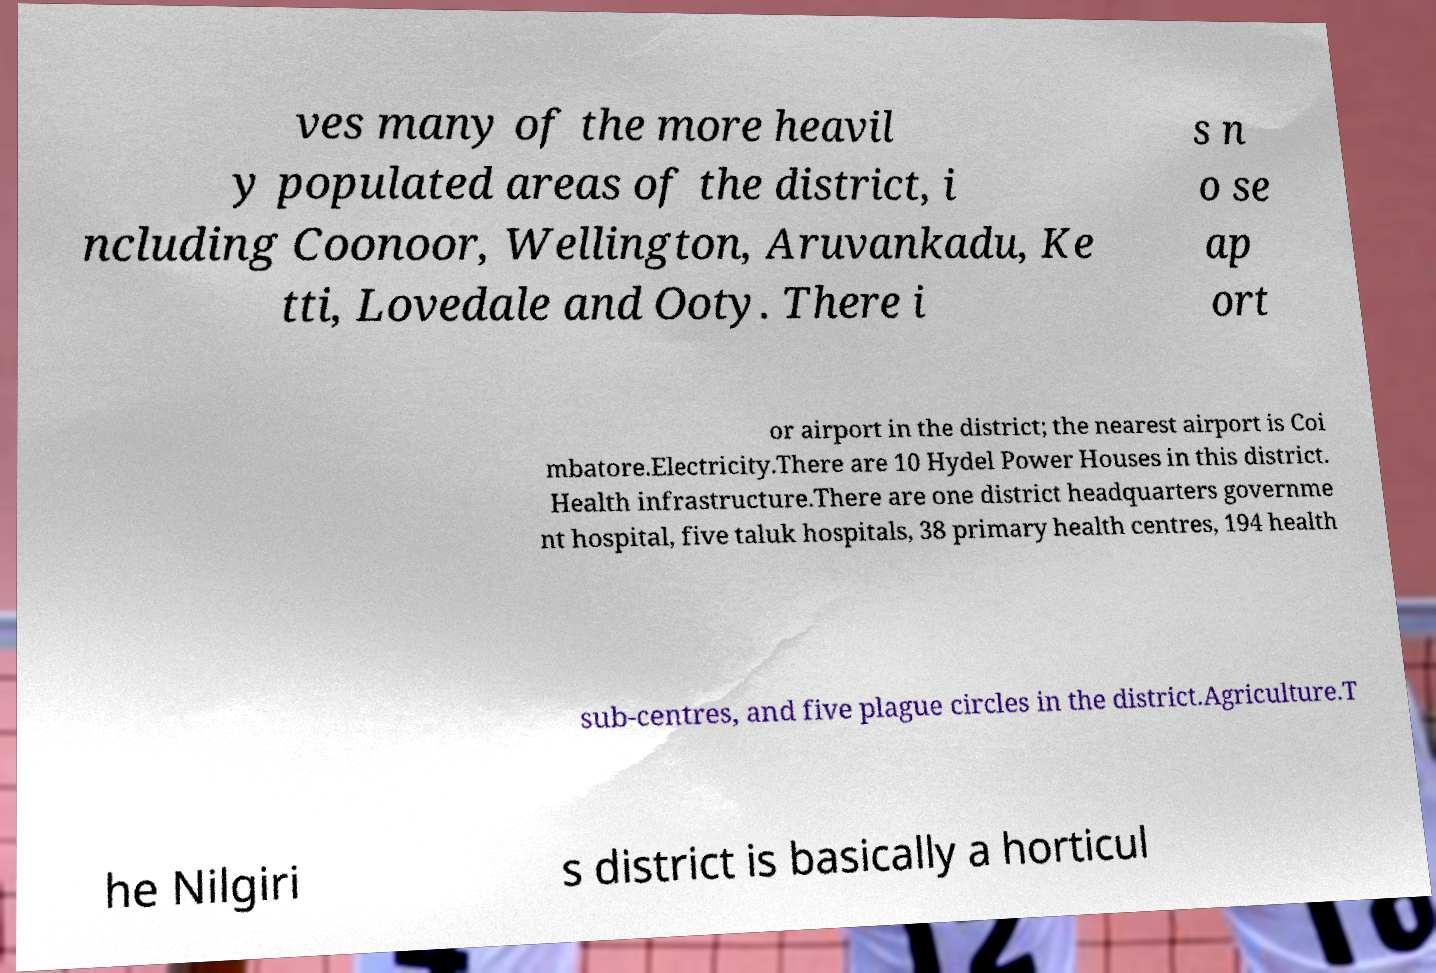There's text embedded in this image that I need extracted. Can you transcribe it verbatim? ves many of the more heavil y populated areas of the district, i ncluding Coonoor, Wellington, Aruvankadu, Ke tti, Lovedale and Ooty. There i s n o se ap ort or airport in the district; the nearest airport is Coi mbatore.Electricity.There are 10 Hydel Power Houses in this district. Health infrastructure.There are one district headquarters governme nt hospital, five taluk hospitals, 38 primary health centres, 194 health sub-centres, and five plague circles in the district.Agriculture.T he Nilgiri s district is basically a horticul 